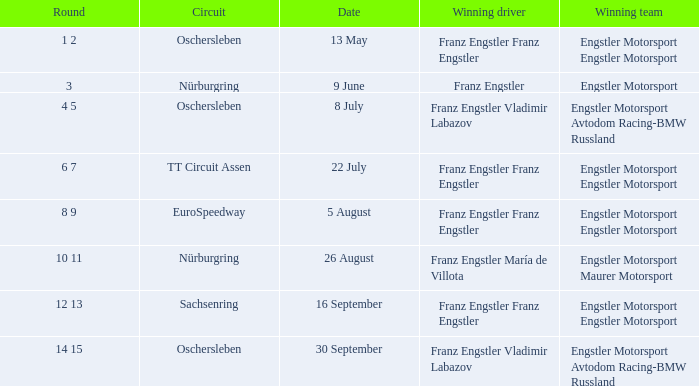Who is the Winning Driver that has a Winning team of Engstler Motorsport Engstler Motorsport and also the Date 22 July? Franz Engstler Franz Engstler. 